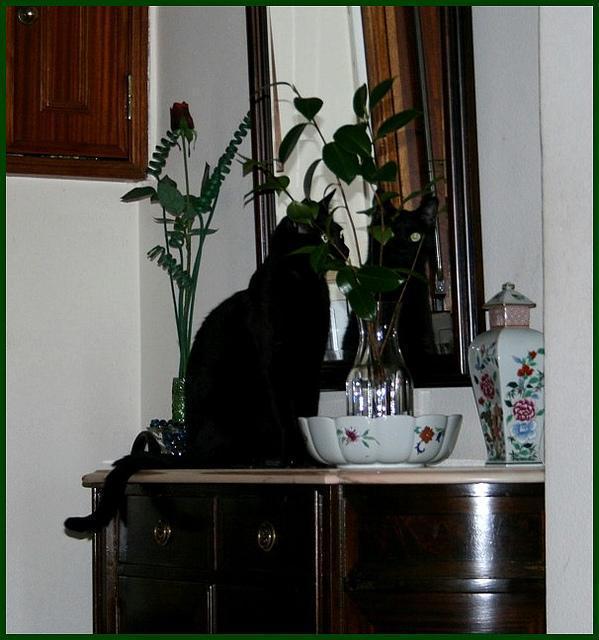How many potted plants can you see?
Give a very brief answer. 2. How many vases are there?
Give a very brief answer. 2. 